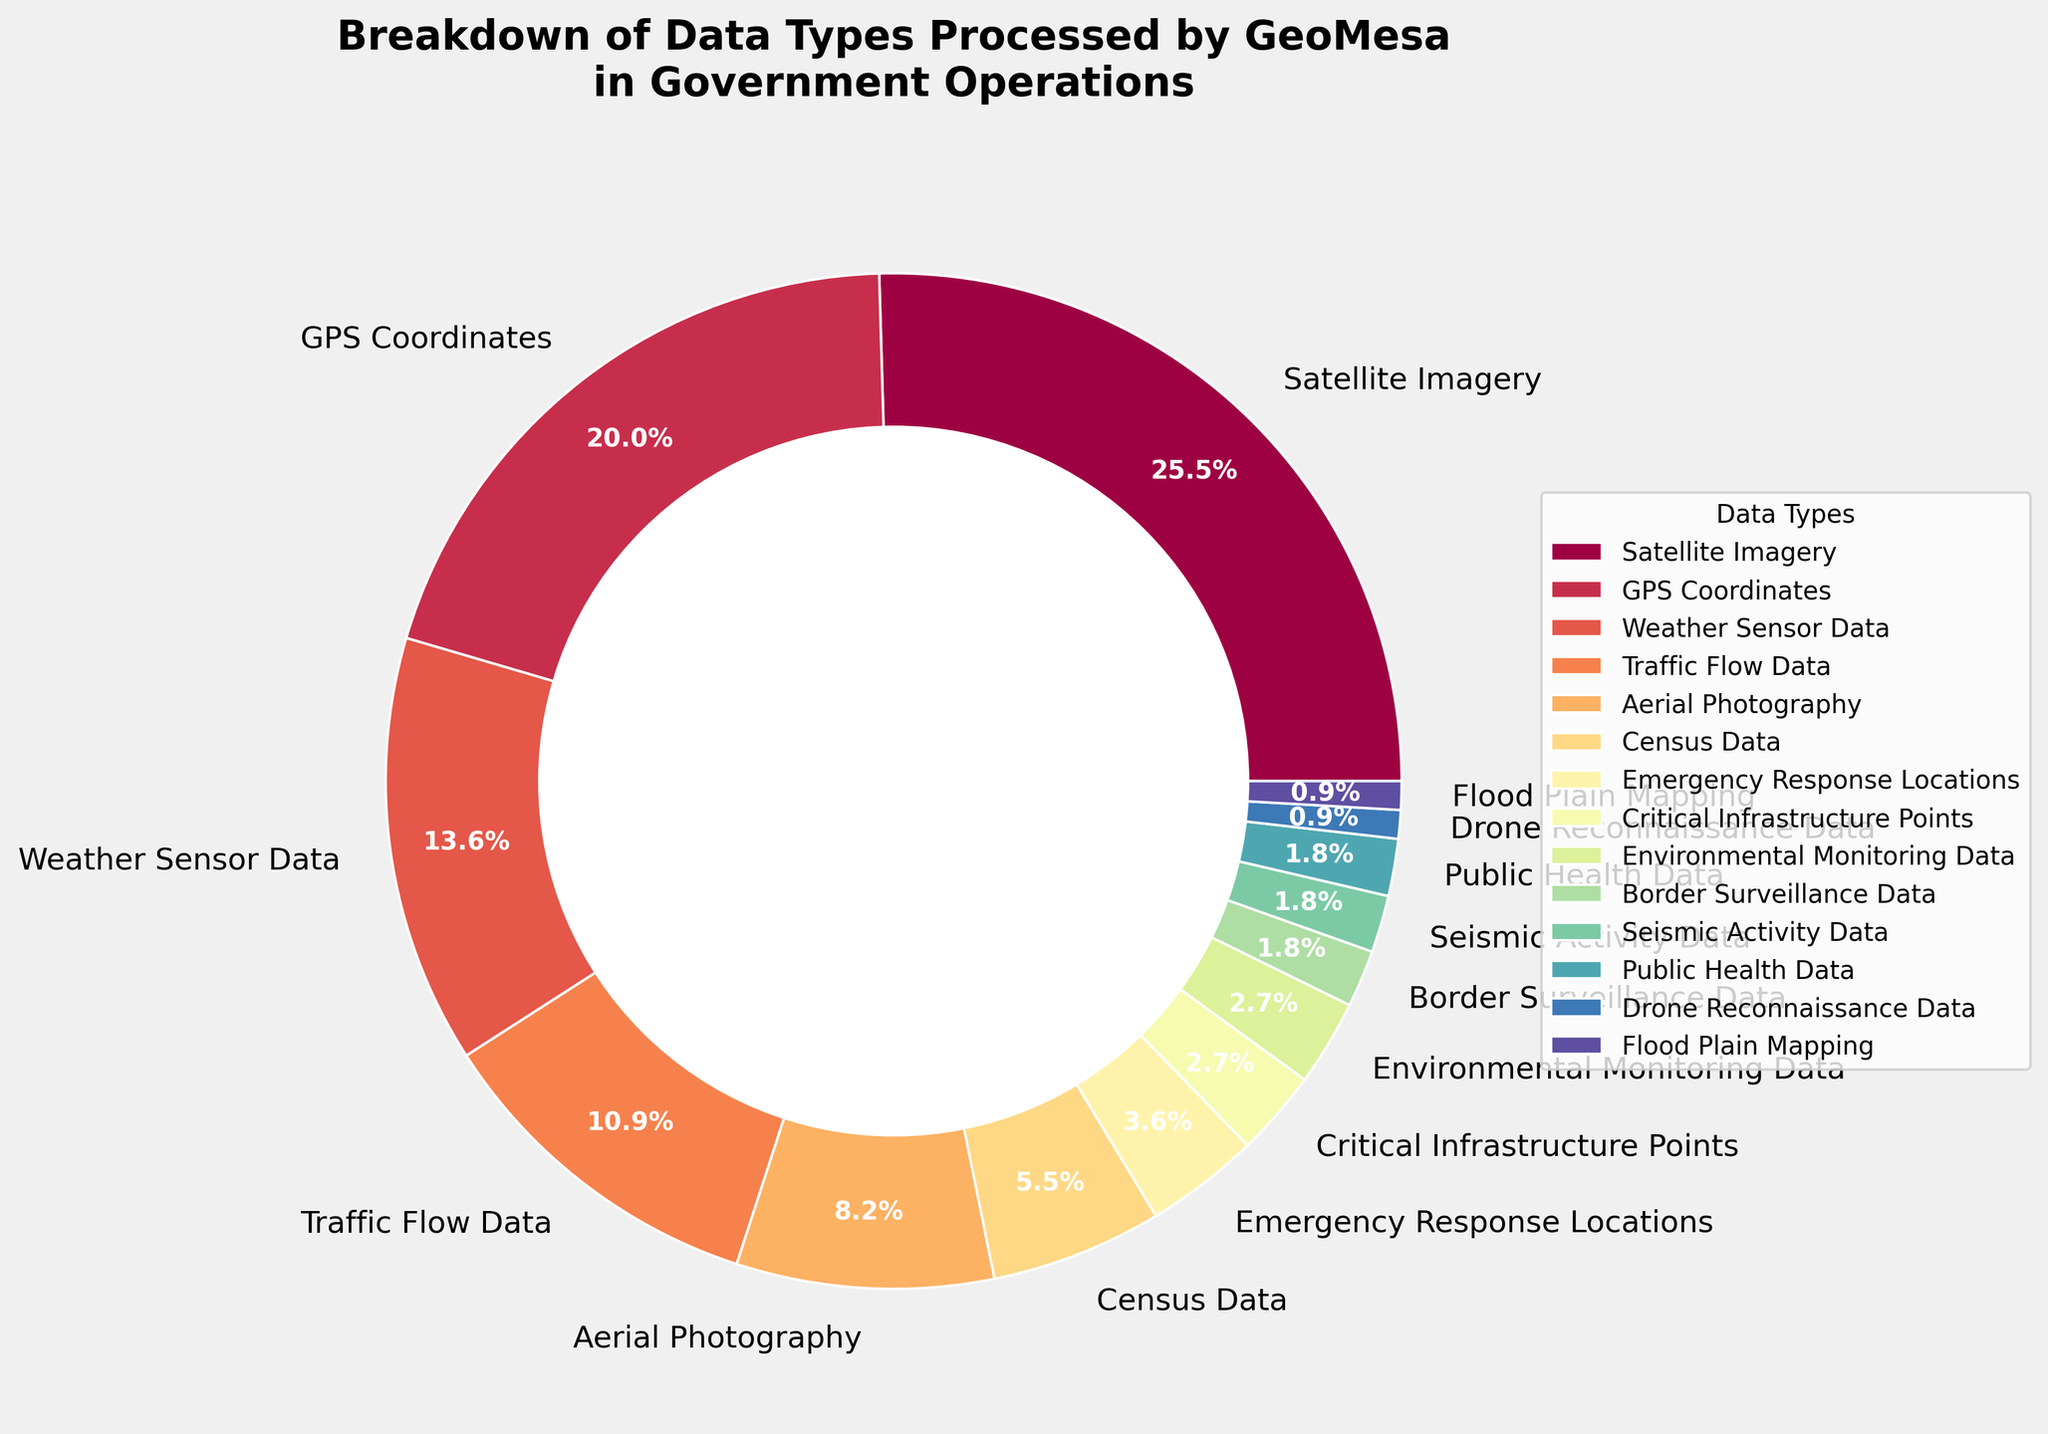Which data type has the highest percentage in the breakdown? The data type with the highest percentage can be identified by looking for the largest slice in the pie chart. The largest slice, labeled "Satellite Imagery", has a percentage of 28%.
Answer: Satellite Imagery How much larger is the percentage of Satellite Imagery compared to GPS Coordinates? To find the difference in percentages, subtract the percentage of GPS Coordinates from that of Satellite Imagery: 28% - 22% = 6%.
Answer: 6% Which visual attribute denotes the critical infrastructure points? The critical infrastructure points are marked as a smaller slice in the pie chart, and according to the legend, it has a color assigned to it that is distinct from the other categories.
Answer: A small slice with a dedicated legend color What is the combined percentage of GPS Coordinates and Weather Sensor Data? Add the percentages of GPS Coordinates and Weather Sensor Data: 22% + 15% = 37%.
Answer: 37% Which data type has the smallest representation in the pie chart? The smallest slice in the pie chart represents the data type with the lowest percentage. According to the legend and the chart, Drone Reconnaissance Data and Flood Plain Mapping both have the smallest percentage of 1%.
Answer: Drone Reconnaissance Data, Flood Plain Mapping What is the ratio of the percentages of Aerial Photography to Census Data? The ratio is calculated by dividing the percentage of Aerial Photography by that of Census Data: 9% / 6% = 1.5.
Answer: 1.5 Is the percentage of Emergency Response Locations greater than the sum of Border Surveillance Data and Seismic Activity Data? Compare the percentage of Emergency Response Locations (4%) with the combined percentage of Border Surveillance Data (2%) and Seismic Activity Data (2%): 4% is equal to 2% + 2%.
Answer: No Which two data types combined make up approximately one-quarter of the total data? Find the two data types whose percentages add up to around 25%. GPS Coordinates (22%) and Border Surveillance Data (2%) combined make 24%, closest to one-quarter.
Answer: GPS Coordinates and Border Surveillance Data What visual elements are used to differentiate between the slices in the pie chart? The slices are differentiated by their distinct colors and the labels placed on each slice, as well as the sizes of the slices which represent the different percentages. Additionally, there is a legend provided to map colors to data types.
Answer: Colors, labels, slice sizes, legend 